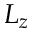<formula> <loc_0><loc_0><loc_500><loc_500>L _ { z }</formula> 